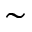<formula> <loc_0><loc_0><loc_500><loc_500>\sim</formula> 